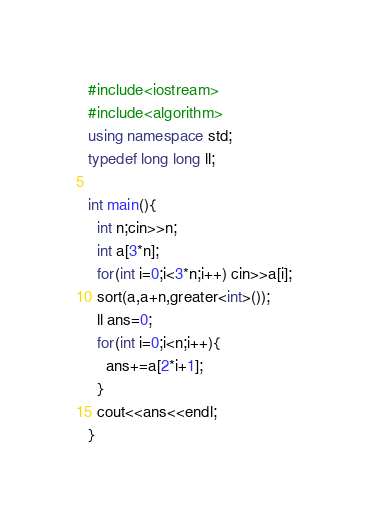Convert code to text. <code><loc_0><loc_0><loc_500><loc_500><_C++_>#include<iostream>
#include<algorithm>
using namespace std;
typedef long long ll;

int main(){
  int n;cin>>n;
  int a[3*n];
  for(int i=0;i<3*n;i++) cin>>a[i];
  sort(a,a+n,greater<int>());
  ll ans=0;
  for(int i=0;i<n;i++){
    ans+=a[2*i+1];
  }
  cout<<ans<<endl;
}</code> 